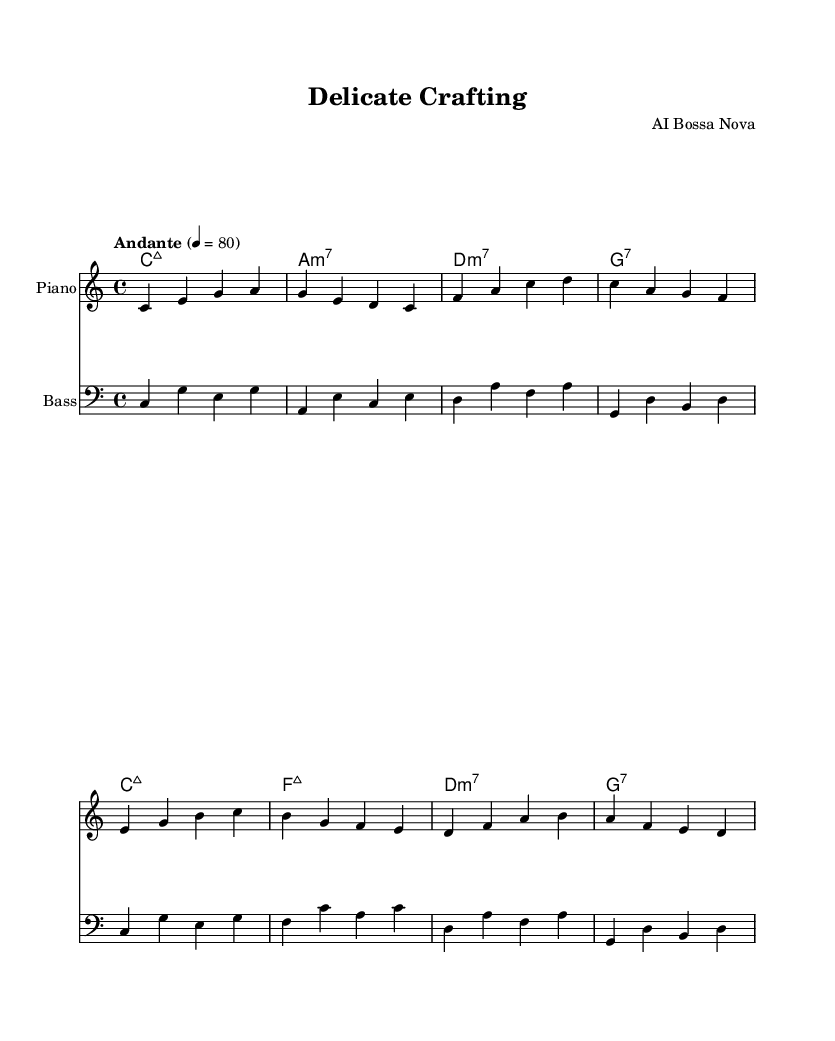What is the key signature of this music? The key signature is C major, which has no sharps or flats.
Answer: C major What is the time signature of this music? The time signature indicates four beats per measure, as denoted by the fraction 4/4.
Answer: 4/4 What is the tempo marking for this piece? The tempo marking "Andante" indicates a moderate pace, which is typically around 76-108 beats per minute.
Answer: Andante How many measures are in the melody section? By counting the individual lines of the melody, we see there are 8 measures.
Answer: 8 Which chords are used in the second half of the piece? Examining the chord changes reveals that the chords used are F major 7 and D minor 7, followed by G7.
Answer: F major 7, D minor 7, G7 What is the overall genre of this piece? The combination of syncopated rhythms and smooth harmonies indicates that this piece belongs to the bossa nova genre, which is a style of Brazilian music.
Answer: Bossa nova 